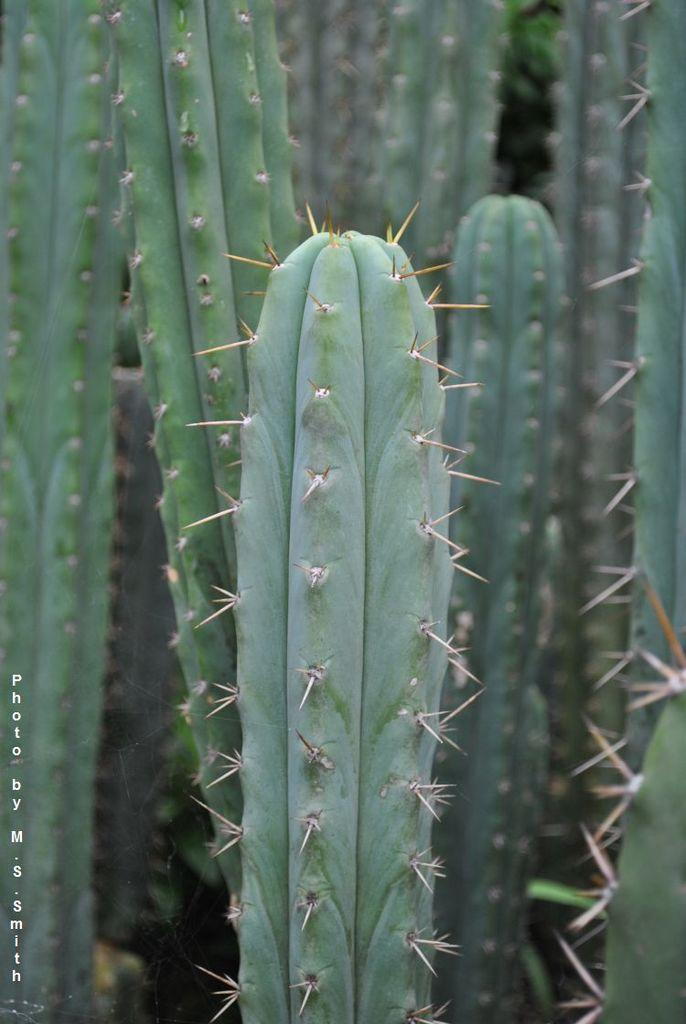What type of plant is in the picture? There is a cactus plant in the picture. What feature can be observed on the cactus plant? The cactus plant has thorns. Can you describe the background of the picture? There are other cactus plants in the background of the picture. What type of button is on the cactus plant in the image? There is no button present on the cactus plant in the image. How much milk can be seen in the image? There is no milk present in the image. 